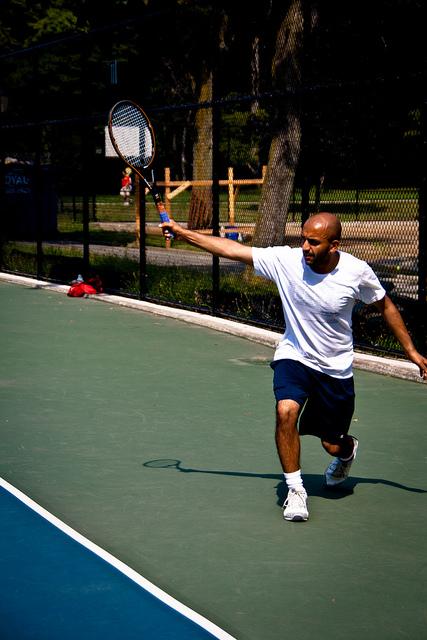What is the man holding?
Give a very brief answer. Tennis racket. How is the player's hair fixed?
Answer briefly. Bald. What is the color of the player short pants?
Give a very brief answer. Blue. What season do you think it may be in the photo?
Quick response, please. Summer. Does this tennis match have corporate sponsors?
Quick response, please. No. Is it a hot day?
Answer briefly. Yes. How many sweatbands is the man wearing?
Be succinct. 0. What color is his racquet?
Be succinct. Black. What is the correct tennis term for stepping over the boundary line?
Be succinct. Fault. What color is the court?
Write a very short answer. Green. What is the sport?
Write a very short answer. Tennis. 